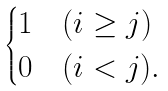Convert formula to latex. <formula><loc_0><loc_0><loc_500><loc_500>\begin{cases} 1 & ( i \geq j ) \\ 0 & ( i < j ) . \end{cases}</formula> 